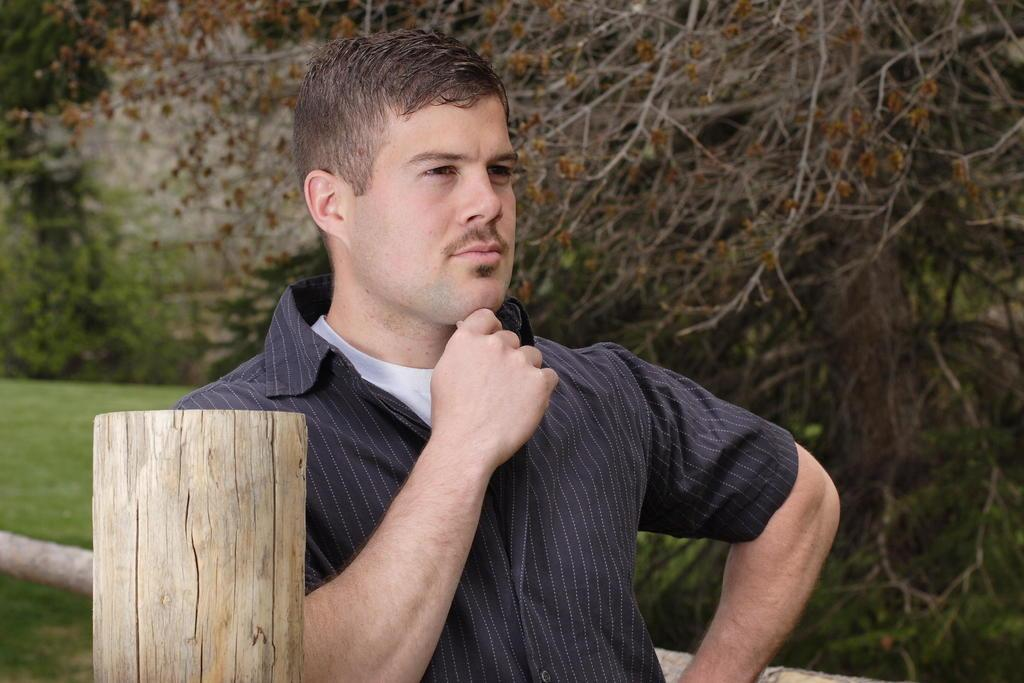What is the main subject of the image? There is a man standing in the image. Where is the man located in relation to the wooden fencing? The man is beside a wooden fencing. What can be seen in the background of the image? There are trees in the background of the image. What type of popcorn is the man eating in the image? There is no popcorn present in the image, so it cannot be determined if the man is eating any. 